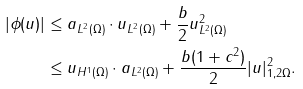Convert formula to latex. <formula><loc_0><loc_0><loc_500><loc_500>| \phi ( u ) | & \leq \| a \| _ { L ^ { 2 } ( \Omega ) } \cdot \| u \| _ { L ^ { 2 } ( \Omega ) } + \frac { b } { 2 } \| u \| ^ { 2 } _ { L ^ { 2 } ( \Omega ) } \\ & \leq \| u \| _ { H ^ { 1 } ( \Omega ) } \cdot \| a \| _ { L ^ { 2 } ( \Omega ) } + \frac { b ( 1 + c ^ { 2 } ) } { 2 } | u | ^ { 2 } _ { 1 , 2 \Omega } .</formula> 